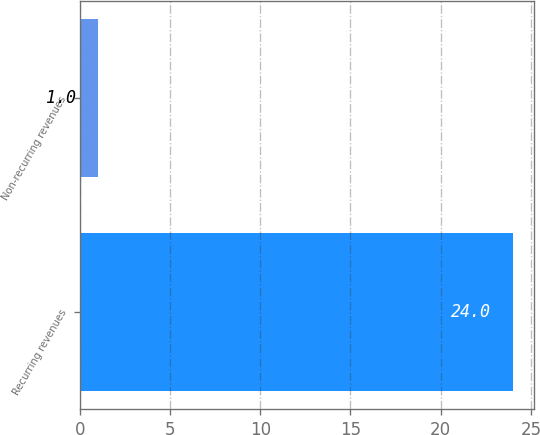Convert chart to OTSL. <chart><loc_0><loc_0><loc_500><loc_500><bar_chart><fcel>Recurring revenues<fcel>Non-recurring revenues<nl><fcel>24<fcel>1<nl></chart> 